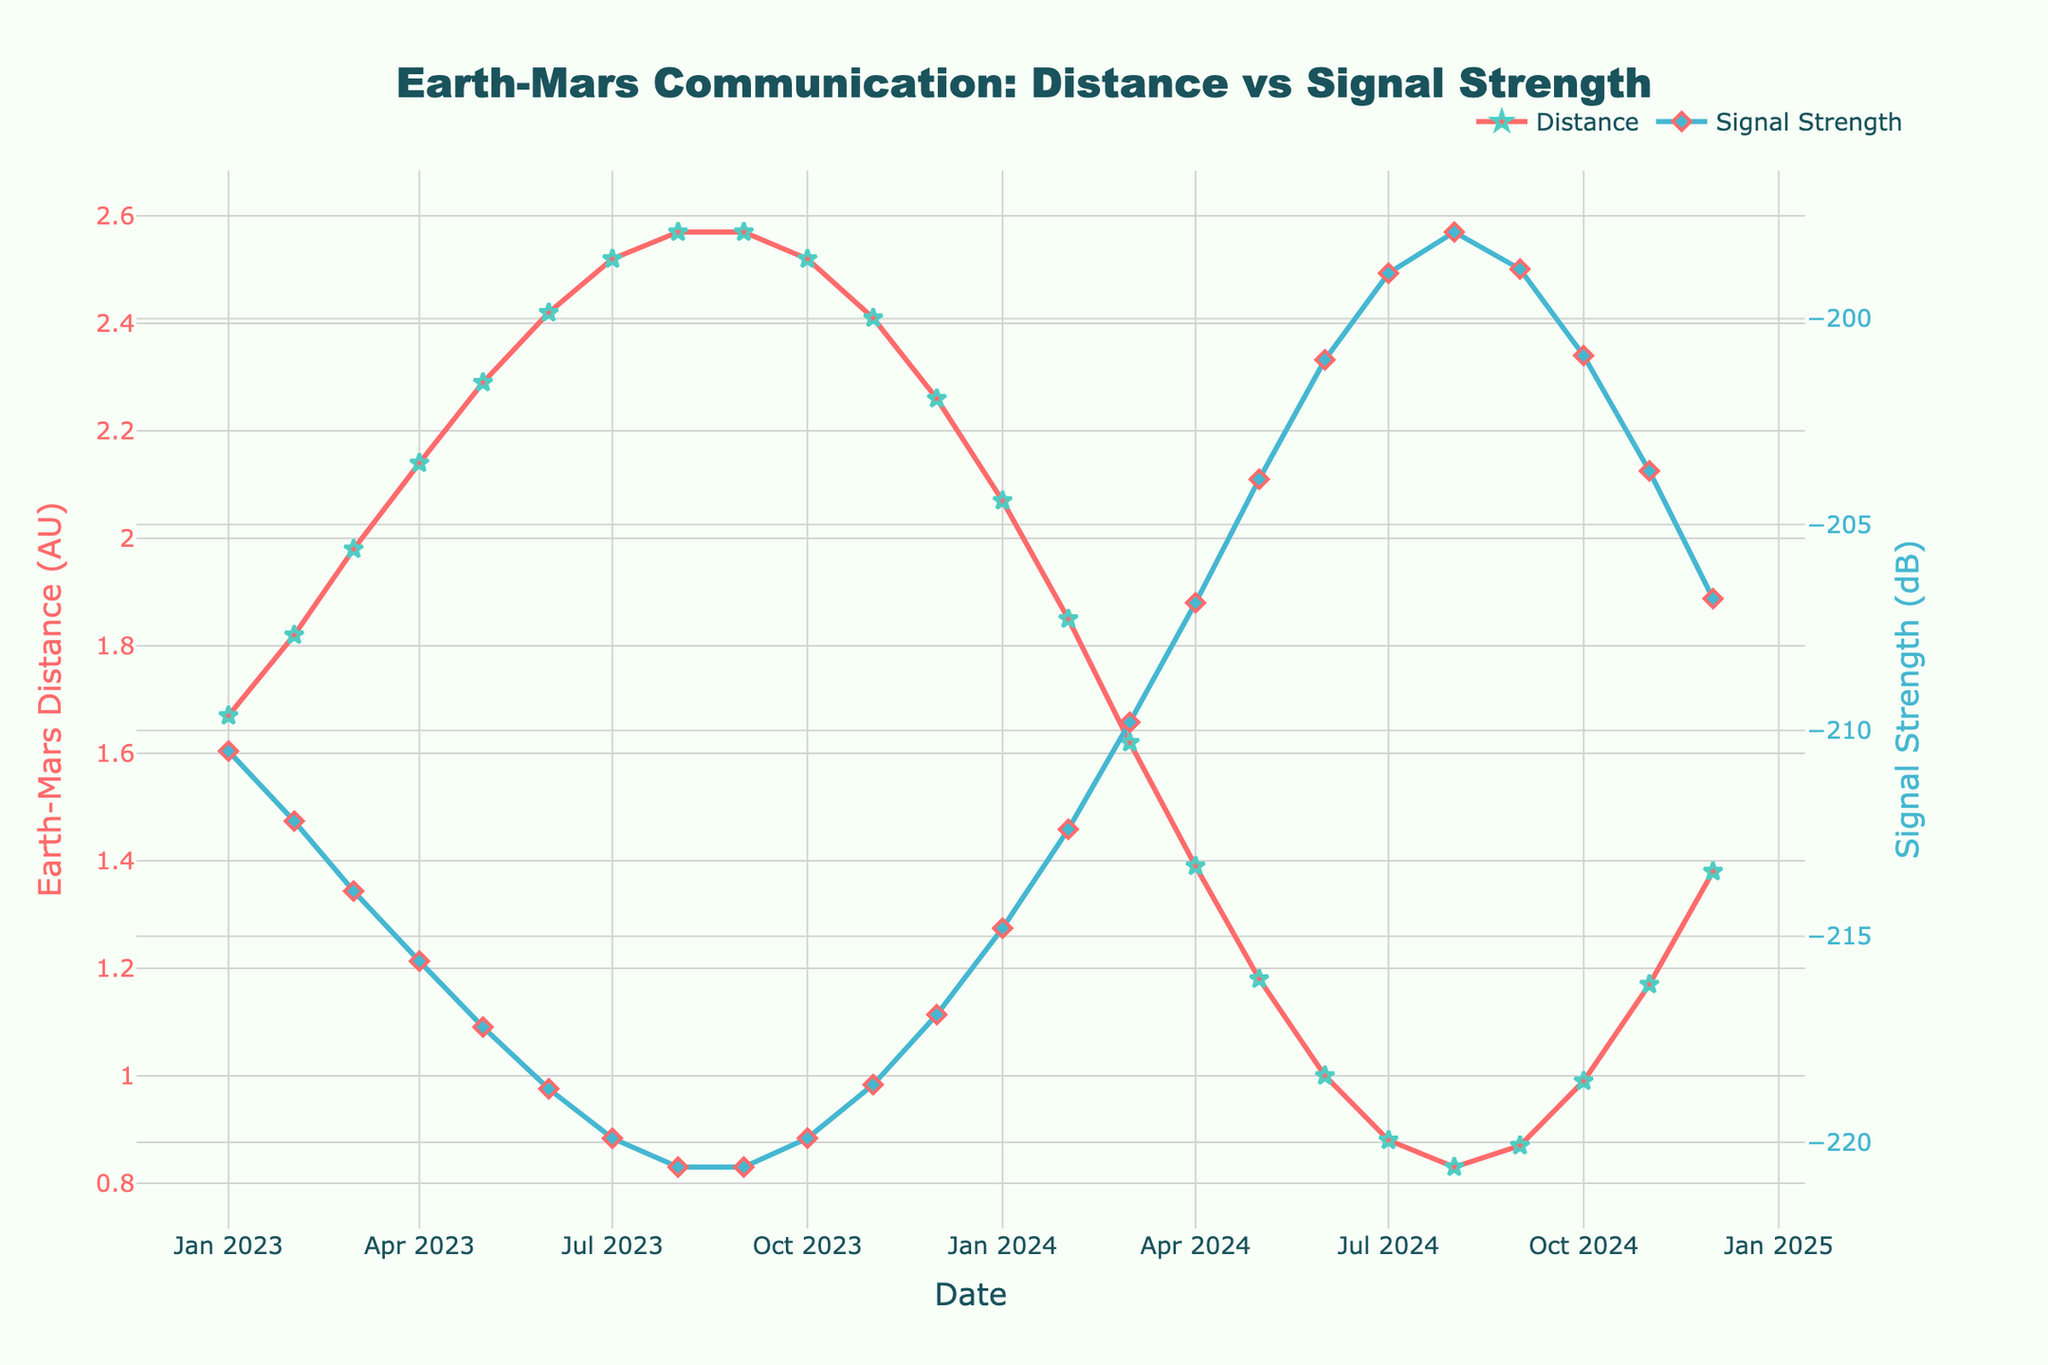What's the general relationship between Earth-Mars distance and signal strength over time? The plot shows that as the Earth-Mars distance increases, the signal strength decreases, and vice versa. This inverse relationship is observed across the timeline presented in the plot.
Answer: Inverse relationship What is the Earth-Mars distance when the signal strength is weakest? The weakest signal strength, around -220.6 dB, is observed in August and September 2023, both times when the Earth-Mars distance is about 2.57 AU.
Answer: 2.57 AU Comparing February 1, 2023, to February 1, 2024, how does the Earth-Mars distance change? On February 1, 2023, the Earth-Mars distance is 1.82 AU. On February 1, 2024, it is 1.85 AU. There is a slight increase in distance over the year.
Answer: Slight increase Considering the maximum and minimum signal strengths shown, what is the difference between them? The maximum signal strength is -197.9 dB in August 2024, and the minimum is -220.6 dB in August and September 2023. The difference is \( -197.9 - (-220.6) = 22.7 \) dB.
Answer: 22.7 dB How does the Earth-Mars distance in July 2024 compare to January 2024? In January 2024, the distance is 2.07 AU while in July 2024, it is 0.88 AU. The distance significantly decreases from January to July.
Answer: Decreases What’s the trend in signal strength from March 1, 2024, to August 1, 2024? From March 1, 2024, to August 1, 2024, the signal strength improves, moving from -209.8 dB to -197.9 dB. This indicates an increasing trend in signal strength.
Answer: Increasing trend Is there any period when the Earth-Mars distance remains constant? Yes, the Earth-Mars distance remains constant at 2.57 AU through August and September 2023.
Answer: August - September 2023 During which period is the Earth-Mars distance decreasing but the signal strength is worsening? From July 2023 to September 2023, the Earth-Mars distance decreases from 2.52 AU to 2.57 AU, but the signal strength worsens from -219.9 dB to -220.6 dB.
Answer: July - September 2023 